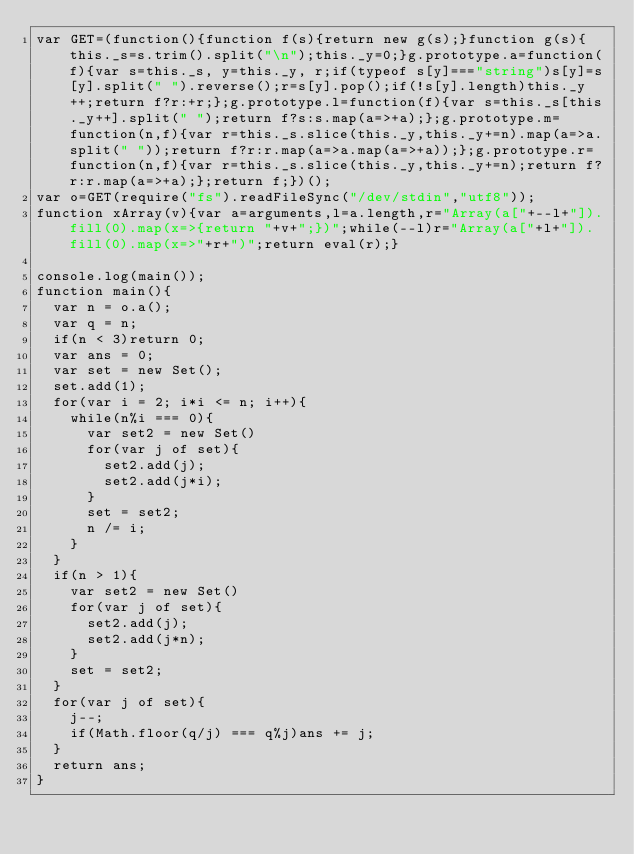<code> <loc_0><loc_0><loc_500><loc_500><_JavaScript_>var GET=(function(){function f(s){return new g(s);}function g(s){this._s=s.trim().split("\n");this._y=0;}g.prototype.a=function(f){var s=this._s, y=this._y, r;if(typeof s[y]==="string")s[y]=s[y].split(" ").reverse();r=s[y].pop();if(!s[y].length)this._y++;return f?r:+r;};g.prototype.l=function(f){var s=this._s[this._y++].split(" ");return f?s:s.map(a=>+a);};g.prototype.m=function(n,f){var r=this._s.slice(this._y,this._y+=n).map(a=>a.split(" "));return f?r:r.map(a=>a.map(a=>+a));};g.prototype.r=function(n,f){var r=this._s.slice(this._y,this._y+=n);return f?r:r.map(a=>+a);};return f;})();
var o=GET(require("fs").readFileSync("/dev/stdin","utf8"));
function xArray(v){var a=arguments,l=a.length,r="Array(a["+--l+"]).fill(0).map(x=>{return "+v+";})";while(--l)r="Array(a["+l+"]).fill(0).map(x=>"+r+")";return eval(r);}

console.log(main());
function main(){
  var n = o.a();
  var q = n;
  if(n < 3)return 0;
  var ans = 0;
  var set = new Set();
  set.add(1);
  for(var i = 2; i*i <= n; i++){
    while(n%i === 0){
      var set2 = new Set()
      for(var j of set){
        set2.add(j);
        set2.add(j*i);
      }
      set = set2;
      n /= i;
    }
  }
  if(n > 1){
    var set2 = new Set()
    for(var j of set){
      set2.add(j);
      set2.add(j*n);
    }
    set = set2;
  }
  for(var j of set){
    j--;
    if(Math.floor(q/j) === q%j)ans += j;
  }
  return ans;
}</code> 